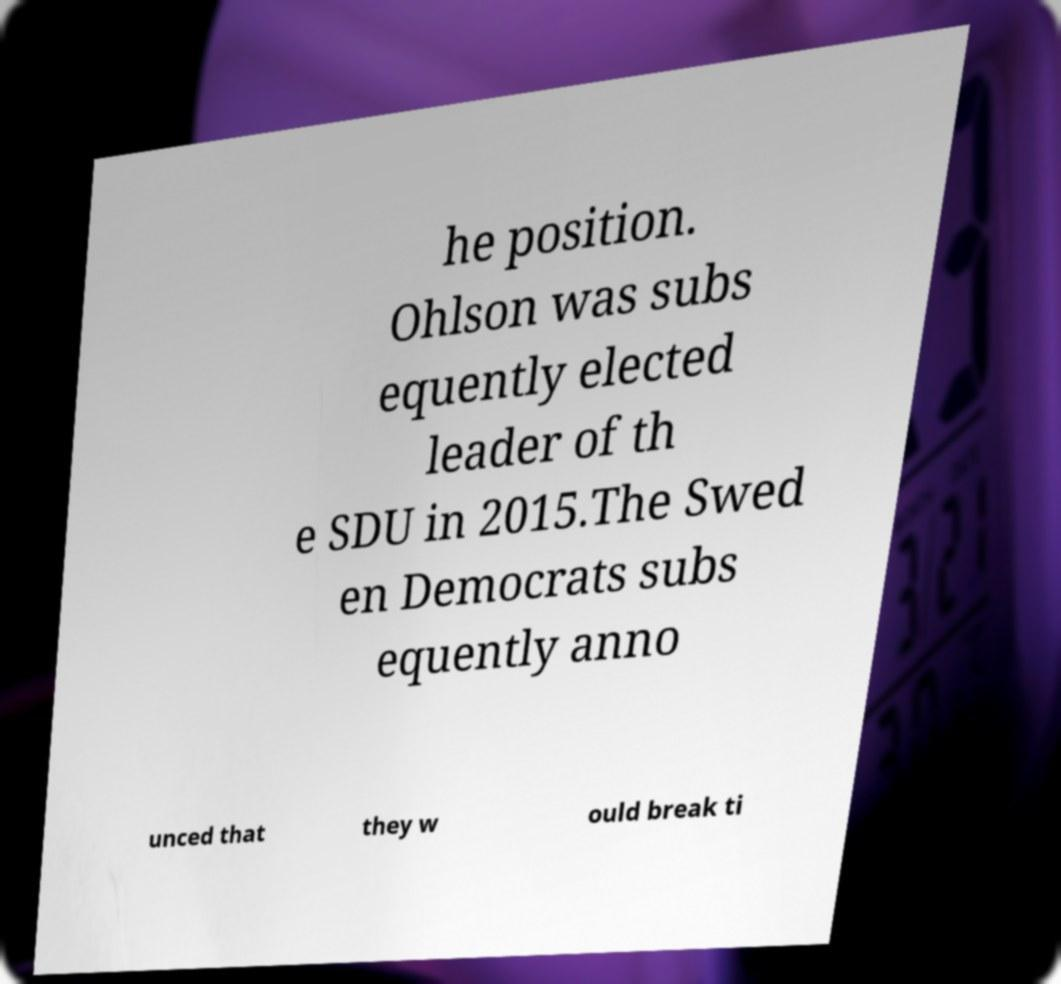Can you read and provide the text displayed in the image?This photo seems to have some interesting text. Can you extract and type it out for me? he position. Ohlson was subs equently elected leader of th e SDU in 2015.The Swed en Democrats subs equently anno unced that they w ould break ti 